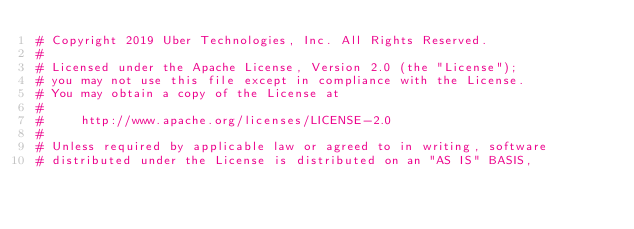<code> <loc_0><loc_0><loc_500><loc_500><_Python_># Copyright 2019 Uber Technologies, Inc. All Rights Reserved.
#
# Licensed under the Apache License, Version 2.0 (the "License");
# you may not use this file except in compliance with the License.
# You may obtain a copy of the License at
#
#     http://www.apache.org/licenses/LICENSE-2.0
#
# Unless required by applicable law or agreed to in writing, software
# distributed under the License is distributed on an "AS IS" BASIS,</code> 